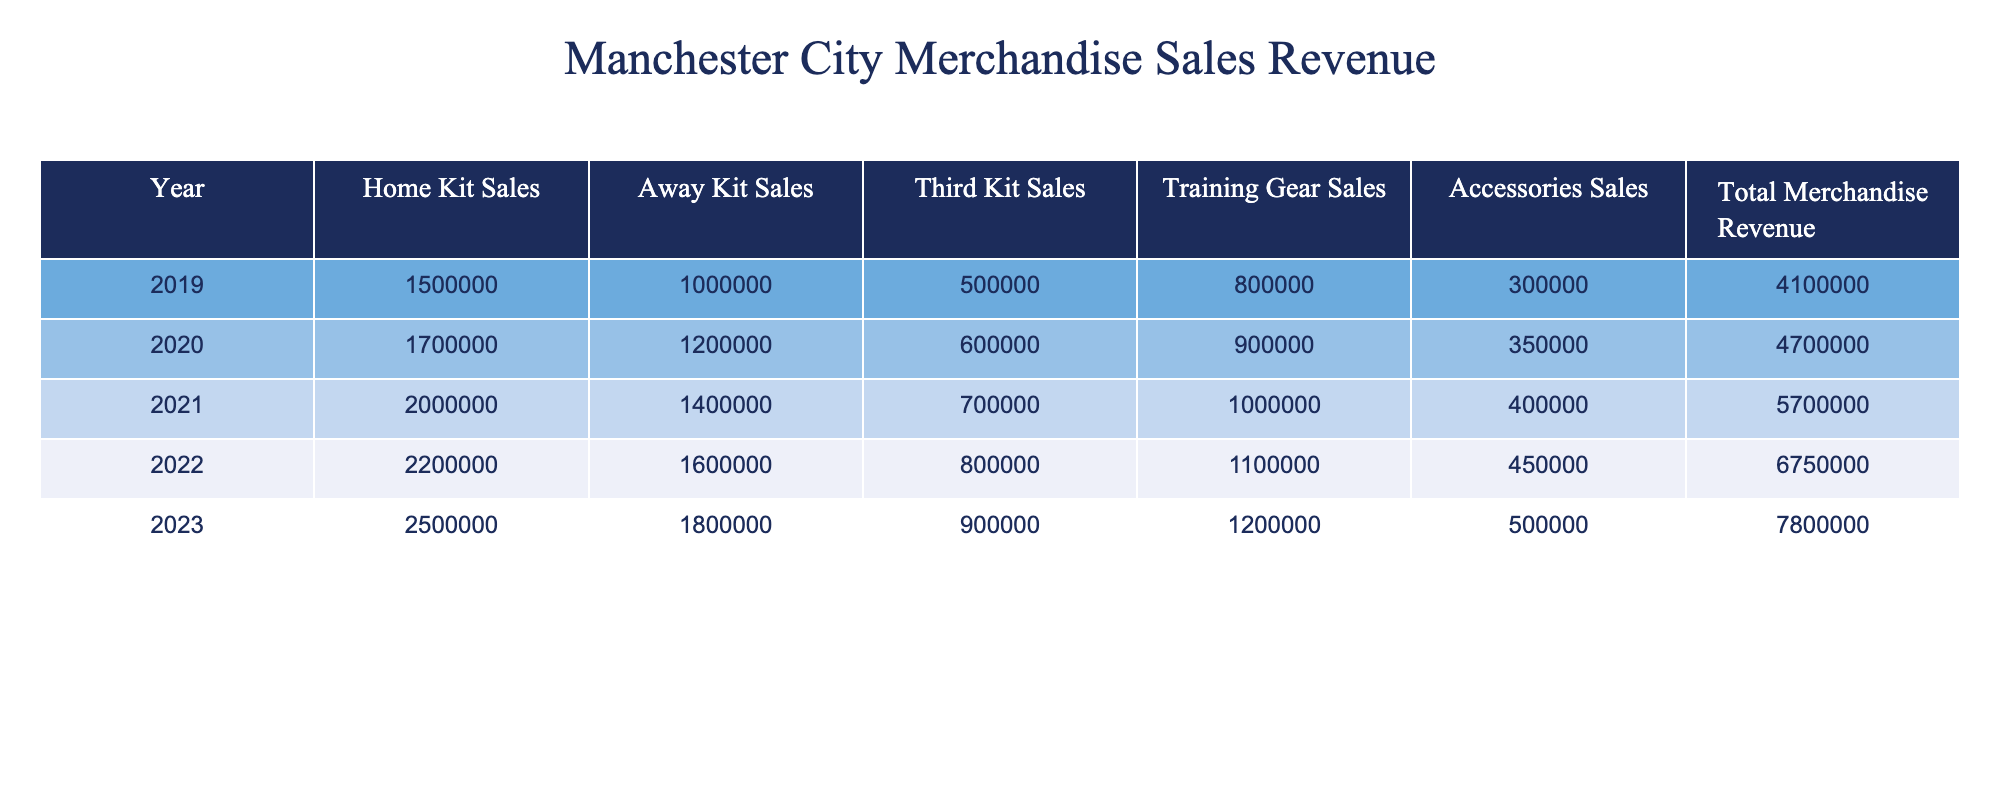What was the total merchandise revenue in 2021? The table shows the total merchandise revenue for each year. In 2021, the total merchandise revenue is listed as £5,700,000.
Answer: £5,700,000 Which year had the highest home kit sales? By comparing the home kit sales year by year in the table, we see that 2023 had the highest home kit sales at £2,500,000.
Answer: 2023 What is the average sales of accessories over the five years? To find the average, we add the accessory sales from each year (300,000 + 350,000 + 400,000 + 450,000 + 500,000 = 2,000,000) and divide by 5, resulting in an average of £400,000.
Answer: £400,000 Did away kit sales increase every year from 2019 to 2023? By reviewing the away kit sales figures for each year, they consistently increased: 1,000,000 (2019) to 1,800,000 (2023), confirming that sales increased each year.
Answer: Yes What was the percentage increase in total merchandise revenue from 2019 to 2023? First, calculate the increase: £7,800,000 (2023) - £4,100,000 (2019) = £3,700,000. Then, to find the percentage increase, we use the formula (increase/original) × 100: (£3,700,000 / £4,100,000) × 100 ≈ 90.24%.
Answer: 90.24% Which kit type had the smallest revenue in 2020? Review the sales figures for each kit in 2020: Home Kit (1,700,000), Away Kit (1,200,000), Third Kit (600,000), Training Gear (900,000), Accessories (350,000). The Third Kit had the smallest revenue at £600,000.
Answer: Third Kit What year had an increase of more than £1,000,000 in total revenue compared to the previous year? The increases in total revenue from year to year can be calculated: 2020 to 2021 (£4,700,000 to £5,700,000), 2021 to 2022 (£5,700,000 to £6,750,000), and 2022 to 2023 (£6,750,000 to £7,800,000). The increase from 2021 to 2022 was £1,050,000, which is more than £1 million.
Answer: 2022 What was the total revenue from training gear sales over the five years? Adding the training gear sales for each year gives the total: £800,000 (2019) + £900,000 (2020) + £1,000,000 (2021) + £1,100,000 (2022) + £1,200,000 (2023) = £5,000,000.
Answer: £5,000,000 Is it true that the third kit sales in 2022 were higher than the accessories sales that year? In 2022, third kit sales were £800,000 and accessories sales were £450,000. Thus, it is true that third kit sales were higher than accessories sales.
Answer: Yes 